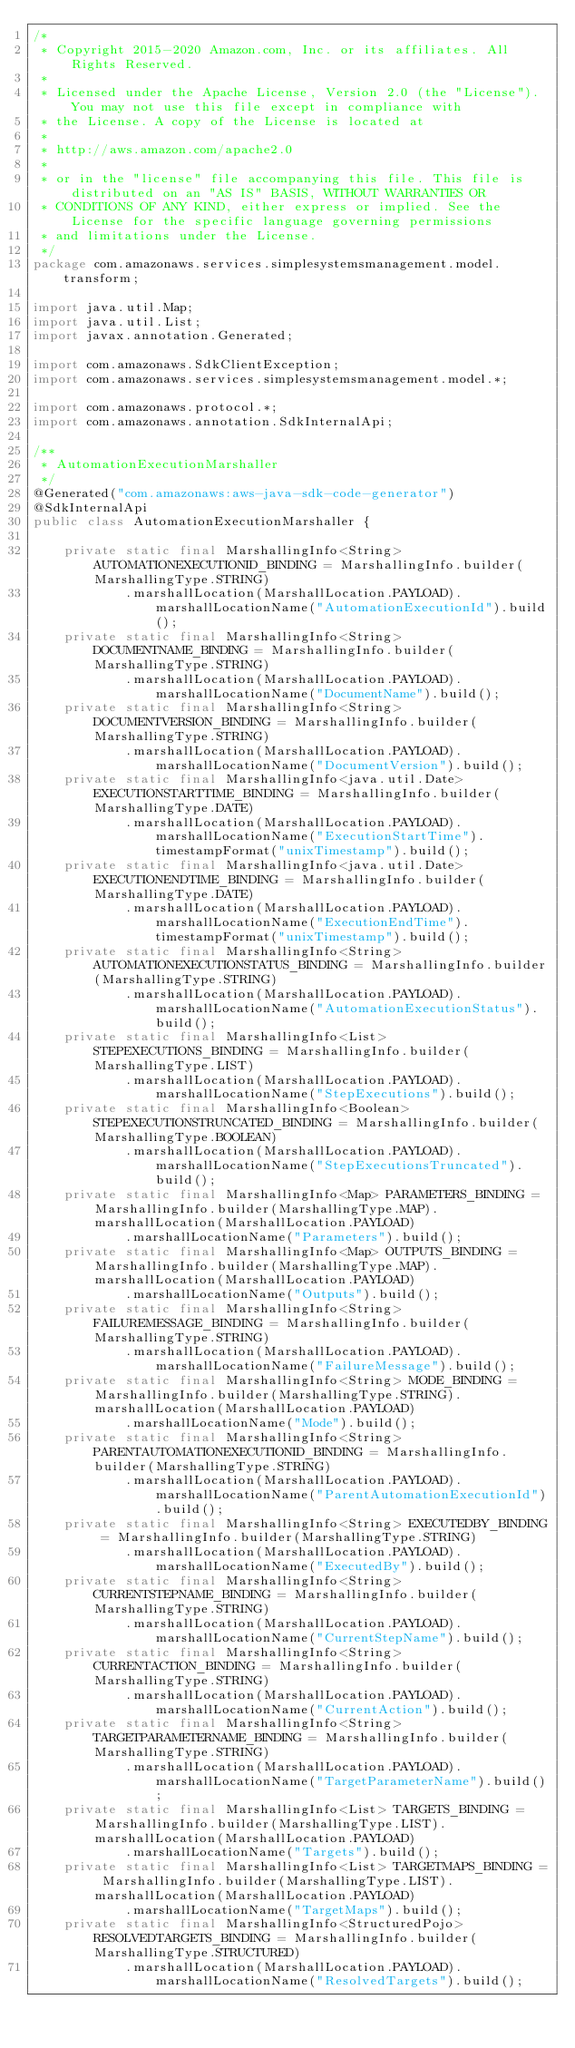<code> <loc_0><loc_0><loc_500><loc_500><_Java_>/*
 * Copyright 2015-2020 Amazon.com, Inc. or its affiliates. All Rights Reserved.
 * 
 * Licensed under the Apache License, Version 2.0 (the "License"). You may not use this file except in compliance with
 * the License. A copy of the License is located at
 * 
 * http://aws.amazon.com/apache2.0
 * 
 * or in the "license" file accompanying this file. This file is distributed on an "AS IS" BASIS, WITHOUT WARRANTIES OR
 * CONDITIONS OF ANY KIND, either express or implied. See the License for the specific language governing permissions
 * and limitations under the License.
 */
package com.amazonaws.services.simplesystemsmanagement.model.transform;

import java.util.Map;
import java.util.List;
import javax.annotation.Generated;

import com.amazonaws.SdkClientException;
import com.amazonaws.services.simplesystemsmanagement.model.*;

import com.amazonaws.protocol.*;
import com.amazonaws.annotation.SdkInternalApi;

/**
 * AutomationExecutionMarshaller
 */
@Generated("com.amazonaws:aws-java-sdk-code-generator")
@SdkInternalApi
public class AutomationExecutionMarshaller {

    private static final MarshallingInfo<String> AUTOMATIONEXECUTIONID_BINDING = MarshallingInfo.builder(MarshallingType.STRING)
            .marshallLocation(MarshallLocation.PAYLOAD).marshallLocationName("AutomationExecutionId").build();
    private static final MarshallingInfo<String> DOCUMENTNAME_BINDING = MarshallingInfo.builder(MarshallingType.STRING)
            .marshallLocation(MarshallLocation.PAYLOAD).marshallLocationName("DocumentName").build();
    private static final MarshallingInfo<String> DOCUMENTVERSION_BINDING = MarshallingInfo.builder(MarshallingType.STRING)
            .marshallLocation(MarshallLocation.PAYLOAD).marshallLocationName("DocumentVersion").build();
    private static final MarshallingInfo<java.util.Date> EXECUTIONSTARTTIME_BINDING = MarshallingInfo.builder(MarshallingType.DATE)
            .marshallLocation(MarshallLocation.PAYLOAD).marshallLocationName("ExecutionStartTime").timestampFormat("unixTimestamp").build();
    private static final MarshallingInfo<java.util.Date> EXECUTIONENDTIME_BINDING = MarshallingInfo.builder(MarshallingType.DATE)
            .marshallLocation(MarshallLocation.PAYLOAD).marshallLocationName("ExecutionEndTime").timestampFormat("unixTimestamp").build();
    private static final MarshallingInfo<String> AUTOMATIONEXECUTIONSTATUS_BINDING = MarshallingInfo.builder(MarshallingType.STRING)
            .marshallLocation(MarshallLocation.PAYLOAD).marshallLocationName("AutomationExecutionStatus").build();
    private static final MarshallingInfo<List> STEPEXECUTIONS_BINDING = MarshallingInfo.builder(MarshallingType.LIST)
            .marshallLocation(MarshallLocation.PAYLOAD).marshallLocationName("StepExecutions").build();
    private static final MarshallingInfo<Boolean> STEPEXECUTIONSTRUNCATED_BINDING = MarshallingInfo.builder(MarshallingType.BOOLEAN)
            .marshallLocation(MarshallLocation.PAYLOAD).marshallLocationName("StepExecutionsTruncated").build();
    private static final MarshallingInfo<Map> PARAMETERS_BINDING = MarshallingInfo.builder(MarshallingType.MAP).marshallLocation(MarshallLocation.PAYLOAD)
            .marshallLocationName("Parameters").build();
    private static final MarshallingInfo<Map> OUTPUTS_BINDING = MarshallingInfo.builder(MarshallingType.MAP).marshallLocation(MarshallLocation.PAYLOAD)
            .marshallLocationName("Outputs").build();
    private static final MarshallingInfo<String> FAILUREMESSAGE_BINDING = MarshallingInfo.builder(MarshallingType.STRING)
            .marshallLocation(MarshallLocation.PAYLOAD).marshallLocationName("FailureMessage").build();
    private static final MarshallingInfo<String> MODE_BINDING = MarshallingInfo.builder(MarshallingType.STRING).marshallLocation(MarshallLocation.PAYLOAD)
            .marshallLocationName("Mode").build();
    private static final MarshallingInfo<String> PARENTAUTOMATIONEXECUTIONID_BINDING = MarshallingInfo.builder(MarshallingType.STRING)
            .marshallLocation(MarshallLocation.PAYLOAD).marshallLocationName("ParentAutomationExecutionId").build();
    private static final MarshallingInfo<String> EXECUTEDBY_BINDING = MarshallingInfo.builder(MarshallingType.STRING)
            .marshallLocation(MarshallLocation.PAYLOAD).marshallLocationName("ExecutedBy").build();
    private static final MarshallingInfo<String> CURRENTSTEPNAME_BINDING = MarshallingInfo.builder(MarshallingType.STRING)
            .marshallLocation(MarshallLocation.PAYLOAD).marshallLocationName("CurrentStepName").build();
    private static final MarshallingInfo<String> CURRENTACTION_BINDING = MarshallingInfo.builder(MarshallingType.STRING)
            .marshallLocation(MarshallLocation.PAYLOAD).marshallLocationName("CurrentAction").build();
    private static final MarshallingInfo<String> TARGETPARAMETERNAME_BINDING = MarshallingInfo.builder(MarshallingType.STRING)
            .marshallLocation(MarshallLocation.PAYLOAD).marshallLocationName("TargetParameterName").build();
    private static final MarshallingInfo<List> TARGETS_BINDING = MarshallingInfo.builder(MarshallingType.LIST).marshallLocation(MarshallLocation.PAYLOAD)
            .marshallLocationName("Targets").build();
    private static final MarshallingInfo<List> TARGETMAPS_BINDING = MarshallingInfo.builder(MarshallingType.LIST).marshallLocation(MarshallLocation.PAYLOAD)
            .marshallLocationName("TargetMaps").build();
    private static final MarshallingInfo<StructuredPojo> RESOLVEDTARGETS_BINDING = MarshallingInfo.builder(MarshallingType.STRUCTURED)
            .marshallLocation(MarshallLocation.PAYLOAD).marshallLocationName("ResolvedTargets").build();</code> 